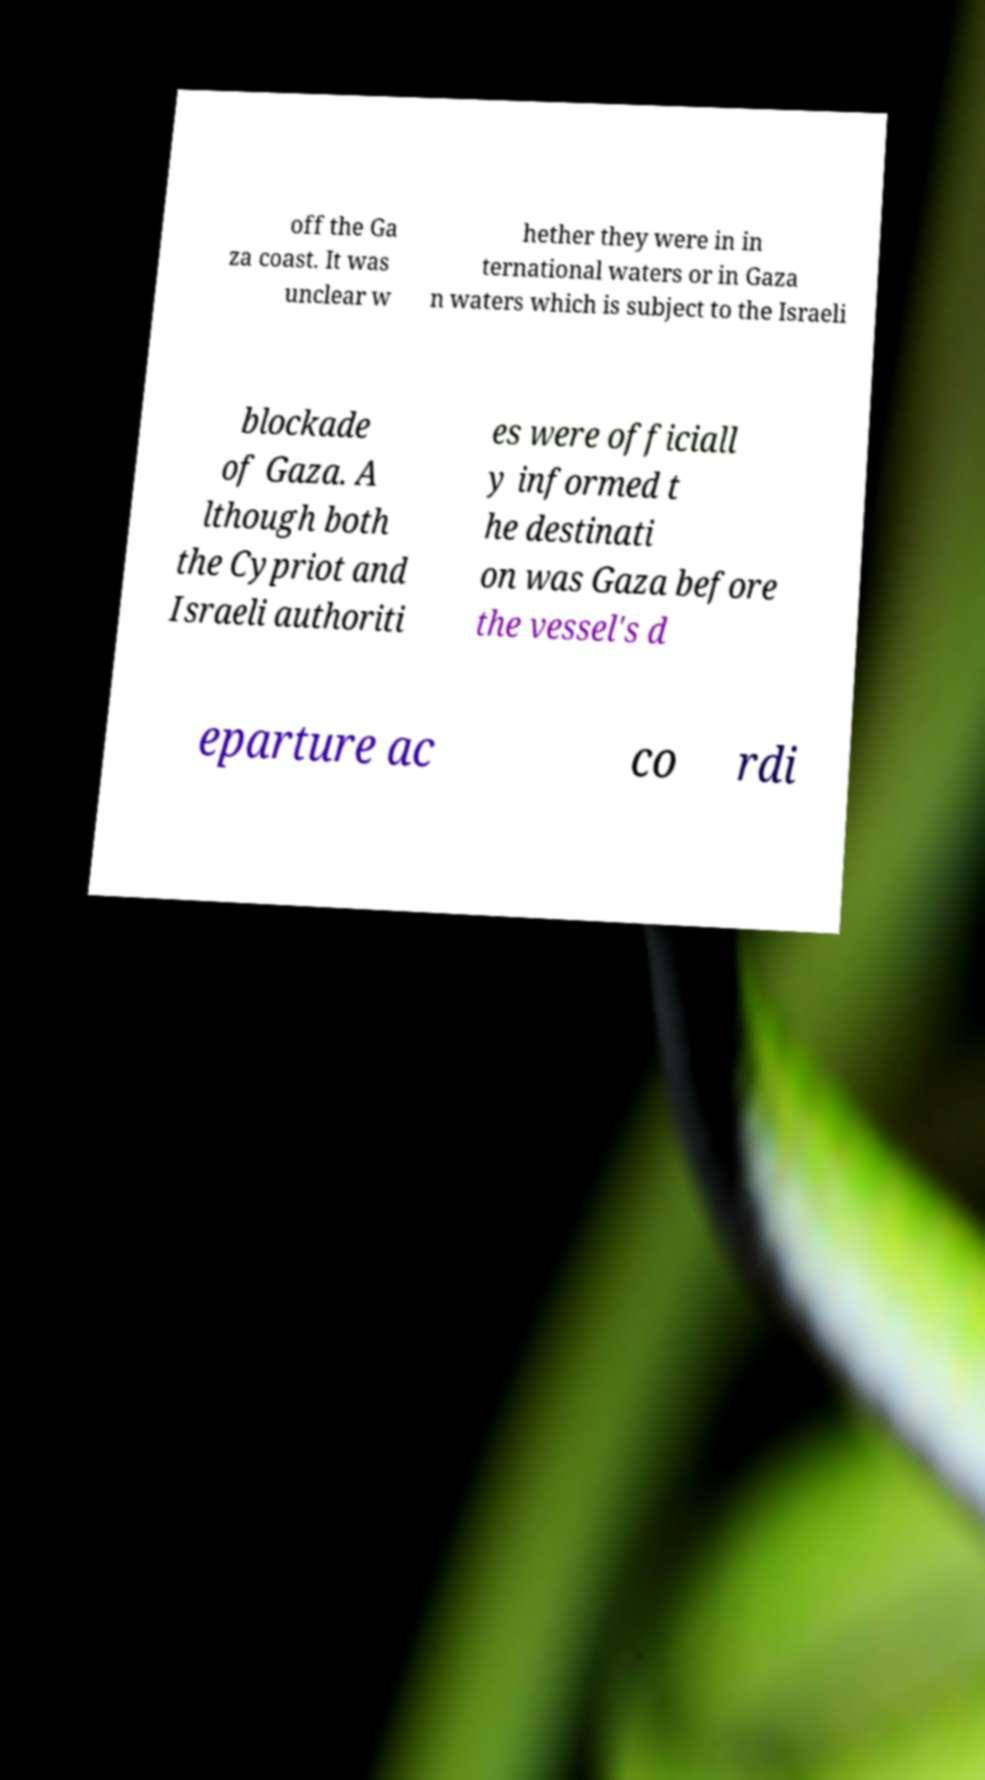Could you extract and type out the text from this image? off the Ga za coast. It was unclear w hether they were in in ternational waters or in Gaza n waters which is subject to the Israeli blockade of Gaza. A lthough both the Cypriot and Israeli authoriti es were officiall y informed t he destinati on was Gaza before the vessel's d eparture ac co rdi 